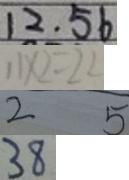<formula> <loc_0><loc_0><loc_500><loc_500>1 2 . 5 6 
 1 1 \times 2 = 2 2 
 2 5 
 3 8</formula> 